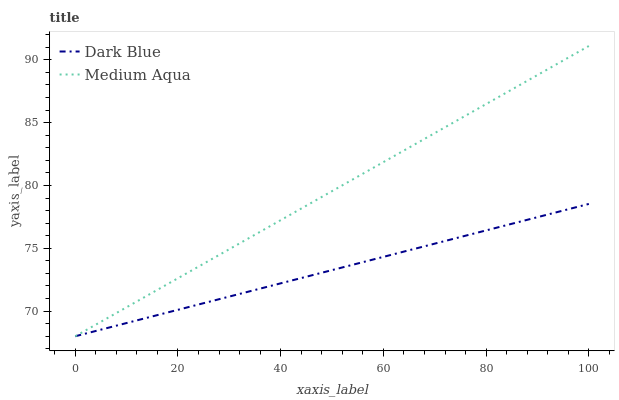Does Dark Blue have the minimum area under the curve?
Answer yes or no. Yes. Does Medium Aqua have the maximum area under the curve?
Answer yes or no. Yes. Does Medium Aqua have the minimum area under the curve?
Answer yes or no. No. Is Dark Blue the smoothest?
Answer yes or no. Yes. Is Medium Aqua the roughest?
Answer yes or no. Yes. Is Medium Aqua the smoothest?
Answer yes or no. No. Does Dark Blue have the lowest value?
Answer yes or no. Yes. Does Medium Aqua have the highest value?
Answer yes or no. Yes. Does Dark Blue intersect Medium Aqua?
Answer yes or no. Yes. Is Dark Blue less than Medium Aqua?
Answer yes or no. No. Is Dark Blue greater than Medium Aqua?
Answer yes or no. No. 